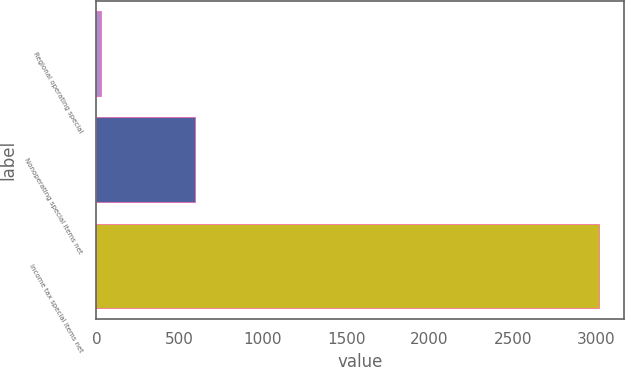<chart> <loc_0><loc_0><loc_500><loc_500><bar_chart><fcel>Regional operating special<fcel>Nonoperating special items net<fcel>Income tax special items net<nl><fcel>29<fcel>594<fcel>3015<nl></chart> 